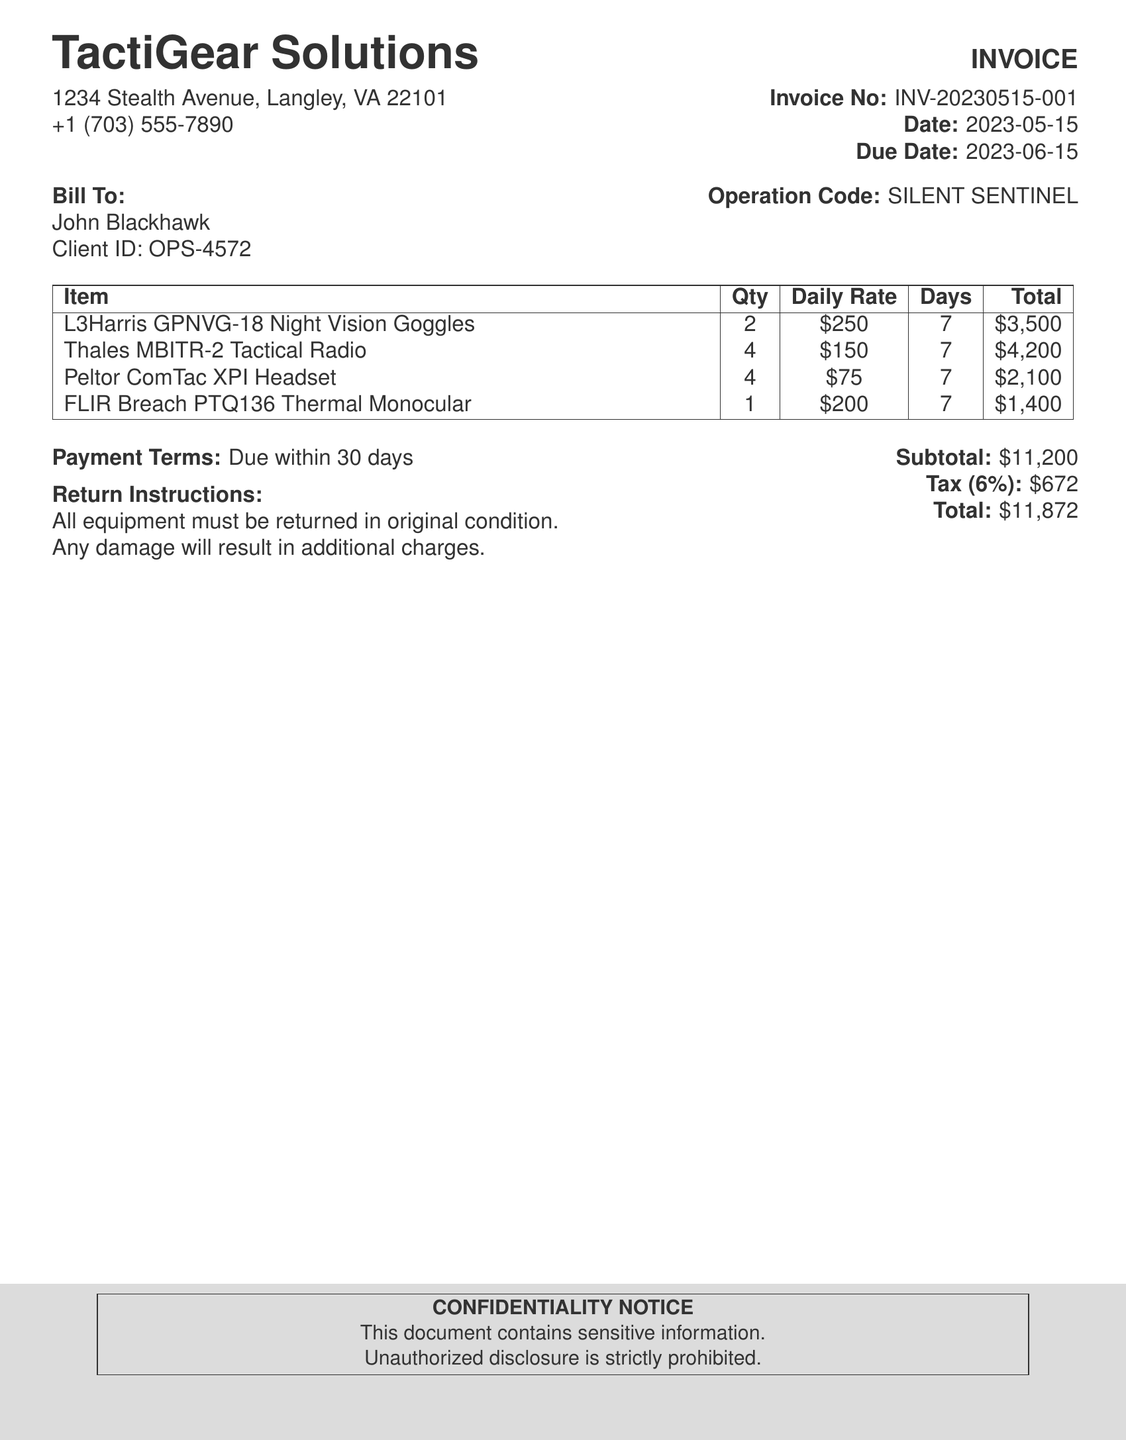What is the name of the company? The company name is listed at the top of the document as TactiGear Solutions.
Answer: TactiGear Solutions What is the invoice number? The invoice number is provided in the document for reference.
Answer: INV-20230515-001 When is the due date for the payment? The due date is explicitly mentioned in the document.
Answer: 2023-06-15 How many total night vision goggles were rented? The quantity of night vision goggles is clearly stated in the table of items.
Answer: 2 What is the subtotal amount? The subtotal is listed in the financial summary section of the document.
Answer: $11,200 What is the tax rate applied? The document specifies the tax rate in percentage.
Answer: 6% How many days were the items rented for? The duration for which the items were rented is indicated in the document.
Answer: 7 What is the total amount due? The total amount due is calculated and presented toward the end of the document.
Answer: $11,872 What are the return instructions? The instructions related to the return of rented equipment are detailed in the document.
Answer: All equipment must be returned in original condition 